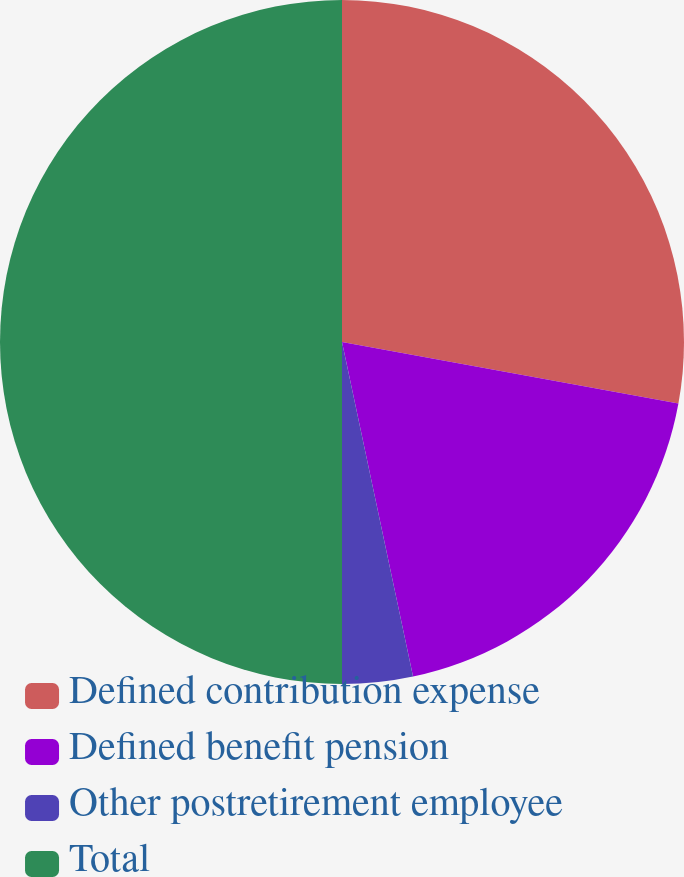Convert chart. <chart><loc_0><loc_0><loc_500><loc_500><pie_chart><fcel>Defined contribution expense<fcel>Defined benefit pension<fcel>Other postretirement employee<fcel>Total<nl><fcel>27.88%<fcel>18.79%<fcel>3.33%<fcel>50.0%<nl></chart> 